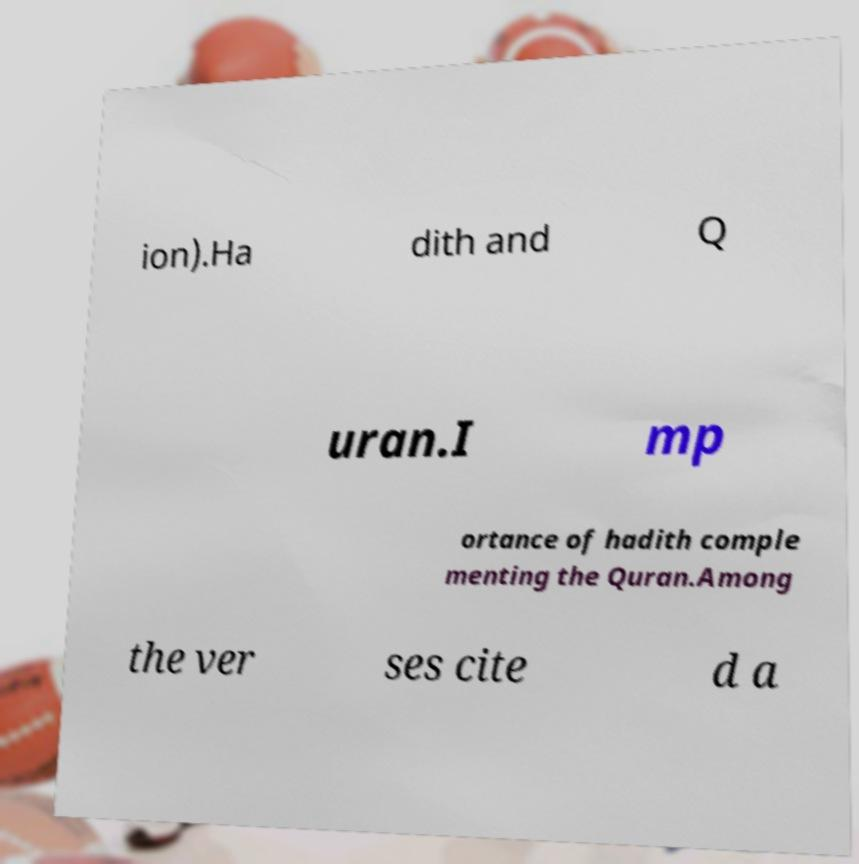Can you read and provide the text displayed in the image?This photo seems to have some interesting text. Can you extract and type it out for me? ion).Ha dith and Q uran.I mp ortance of hadith comple menting the Quran.Among the ver ses cite d a 